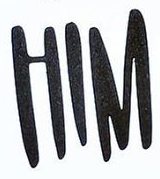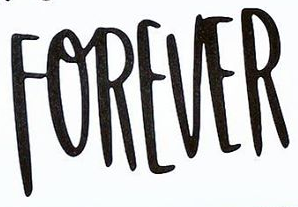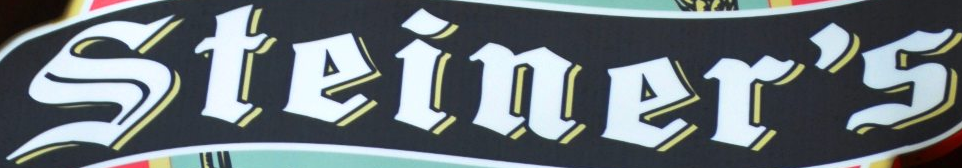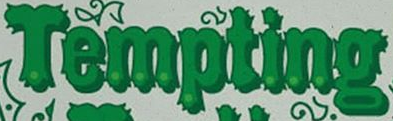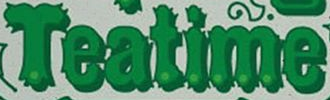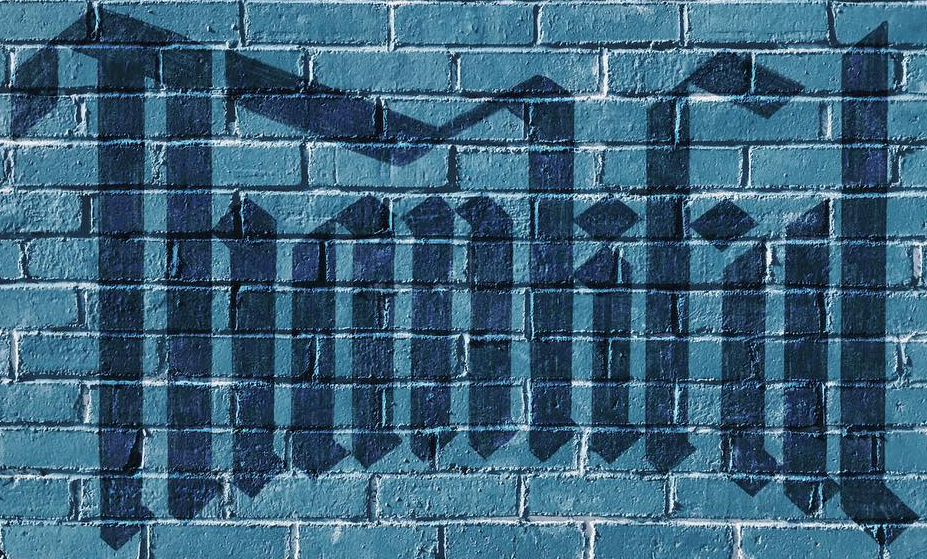Identify the words shown in these images in order, separated by a semicolon. HIM; FOREVER; Steiner's; Tempting; Teatime; Thankful 